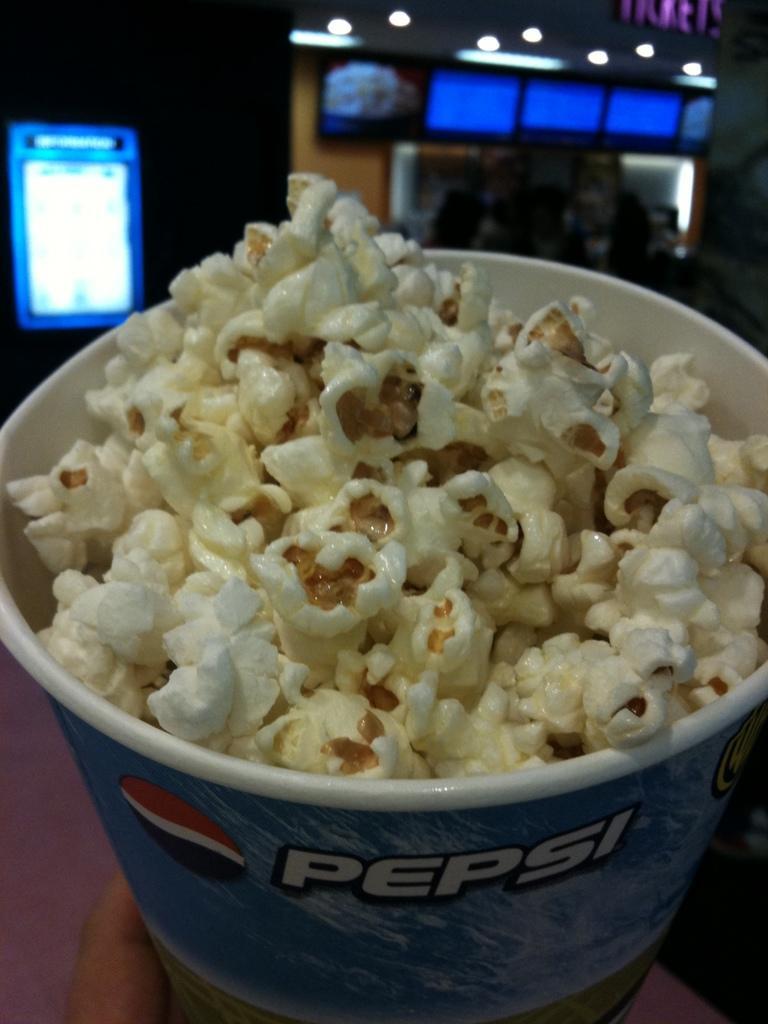Describe this image in one or two sentences. In this picture I can see a paper bucket, on which there is a word written and I see a logo and in the bucket I see the popcorn. In the background I see the lights and few screens. 